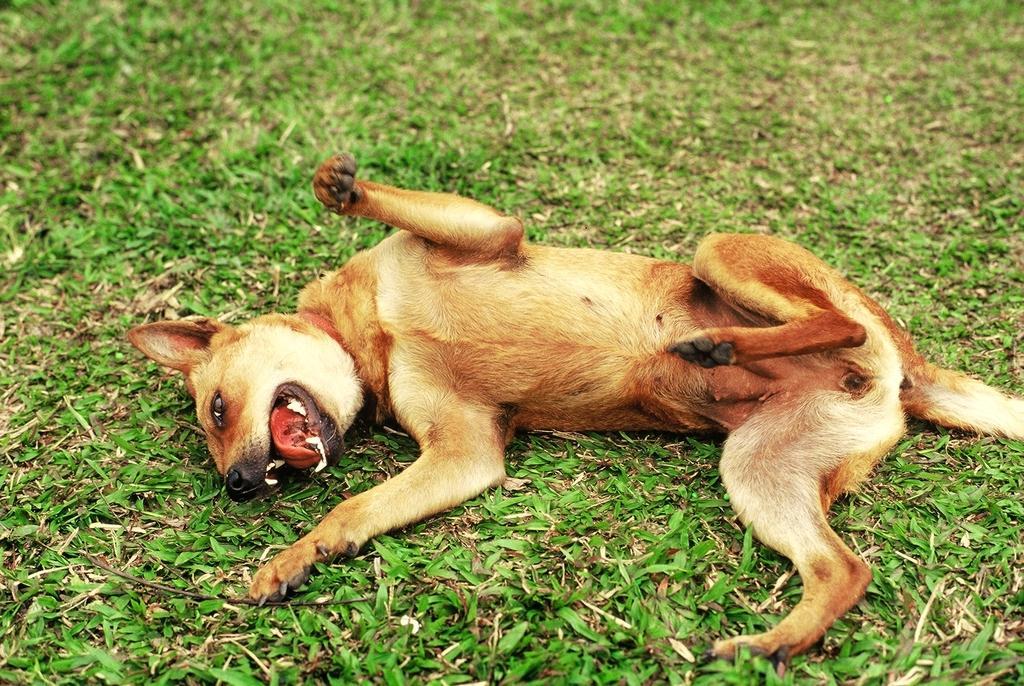Describe this image in one or two sentences. In the center of the image we can see a dog. At the bottom there is grass. 